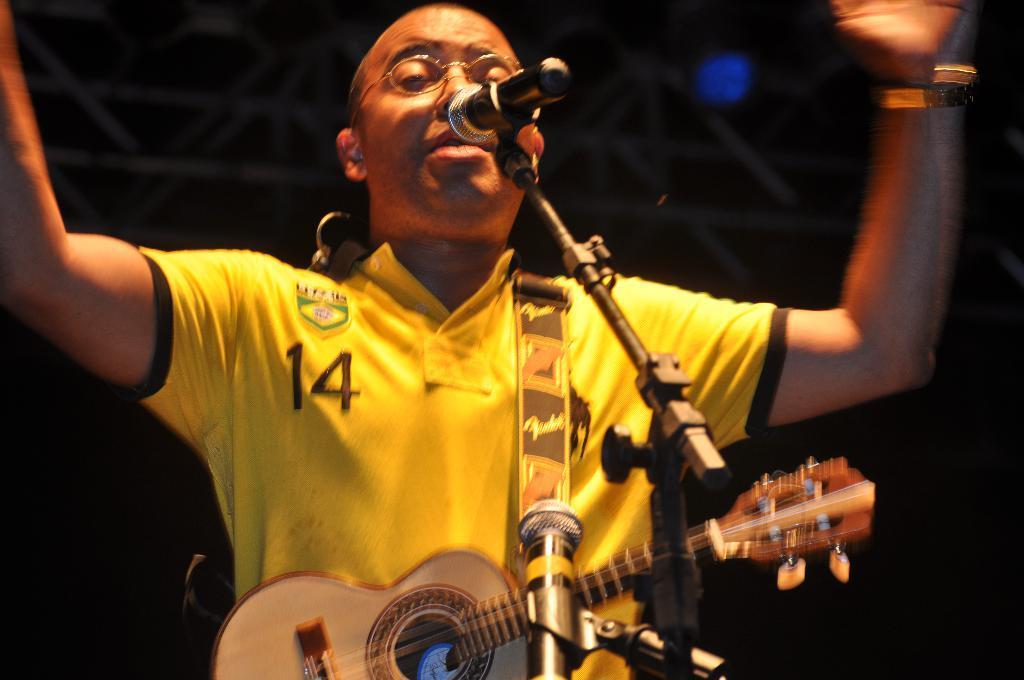Describe this image in one or two sentences. A boy is standing by holding a guitar and he is singing in the microphone. 